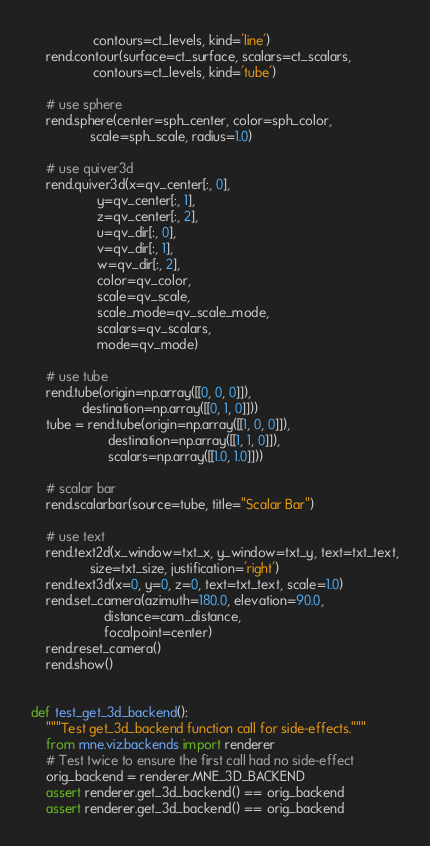Convert code to text. <code><loc_0><loc_0><loc_500><loc_500><_Python_>                 contours=ct_levels, kind='line')
    rend.contour(surface=ct_surface, scalars=ct_scalars,
                 contours=ct_levels, kind='tube')

    # use sphere
    rend.sphere(center=sph_center, color=sph_color,
                scale=sph_scale, radius=1.0)

    # use quiver3d
    rend.quiver3d(x=qv_center[:, 0],
                  y=qv_center[:, 1],
                  z=qv_center[:, 2],
                  u=qv_dir[:, 0],
                  v=qv_dir[:, 1],
                  w=qv_dir[:, 2],
                  color=qv_color,
                  scale=qv_scale,
                  scale_mode=qv_scale_mode,
                  scalars=qv_scalars,
                  mode=qv_mode)

    # use tube
    rend.tube(origin=np.array([[0, 0, 0]]),
              destination=np.array([[0, 1, 0]]))
    tube = rend.tube(origin=np.array([[1, 0, 0]]),
                     destination=np.array([[1, 1, 0]]),
                     scalars=np.array([[1.0, 1.0]]))

    # scalar bar
    rend.scalarbar(source=tube, title="Scalar Bar")

    # use text
    rend.text2d(x_window=txt_x, y_window=txt_y, text=txt_text,
                size=txt_size, justification='right')
    rend.text3d(x=0, y=0, z=0, text=txt_text, scale=1.0)
    rend.set_camera(azimuth=180.0, elevation=90.0,
                    distance=cam_distance,
                    focalpoint=center)
    rend.reset_camera()
    rend.show()


def test_get_3d_backend():
    """Test get_3d_backend function call for side-effects."""
    from mne.viz.backends import renderer
    # Test twice to ensure the first call had no side-effect
    orig_backend = renderer.MNE_3D_BACKEND
    assert renderer.get_3d_backend() == orig_backend
    assert renderer.get_3d_backend() == orig_backend
</code> 